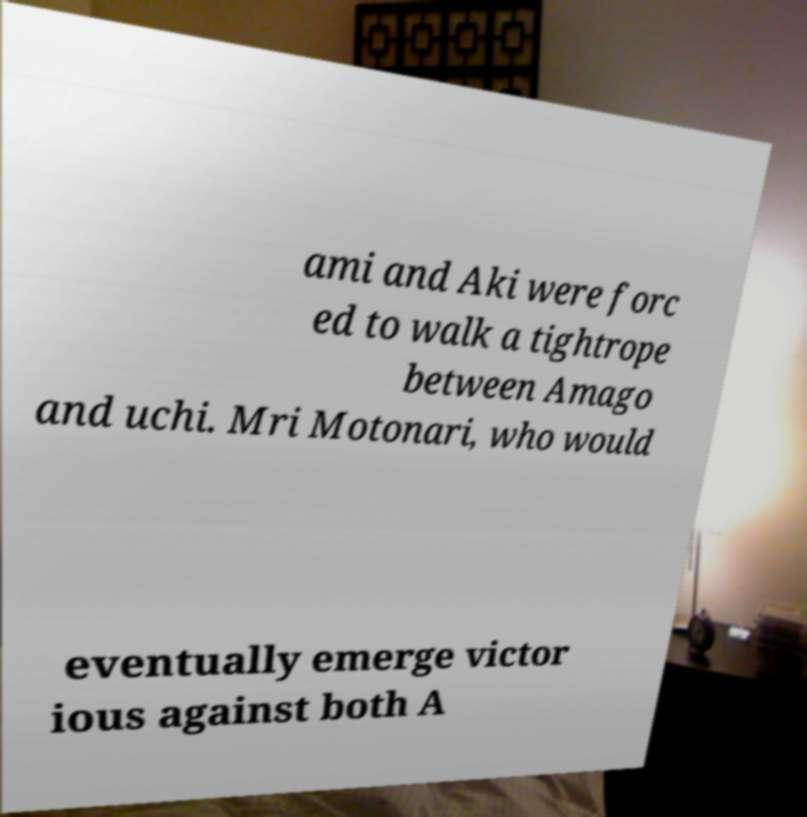Can you read and provide the text displayed in the image?This photo seems to have some interesting text. Can you extract and type it out for me? ami and Aki were forc ed to walk a tightrope between Amago and uchi. Mri Motonari, who would eventually emerge victor ious against both A 